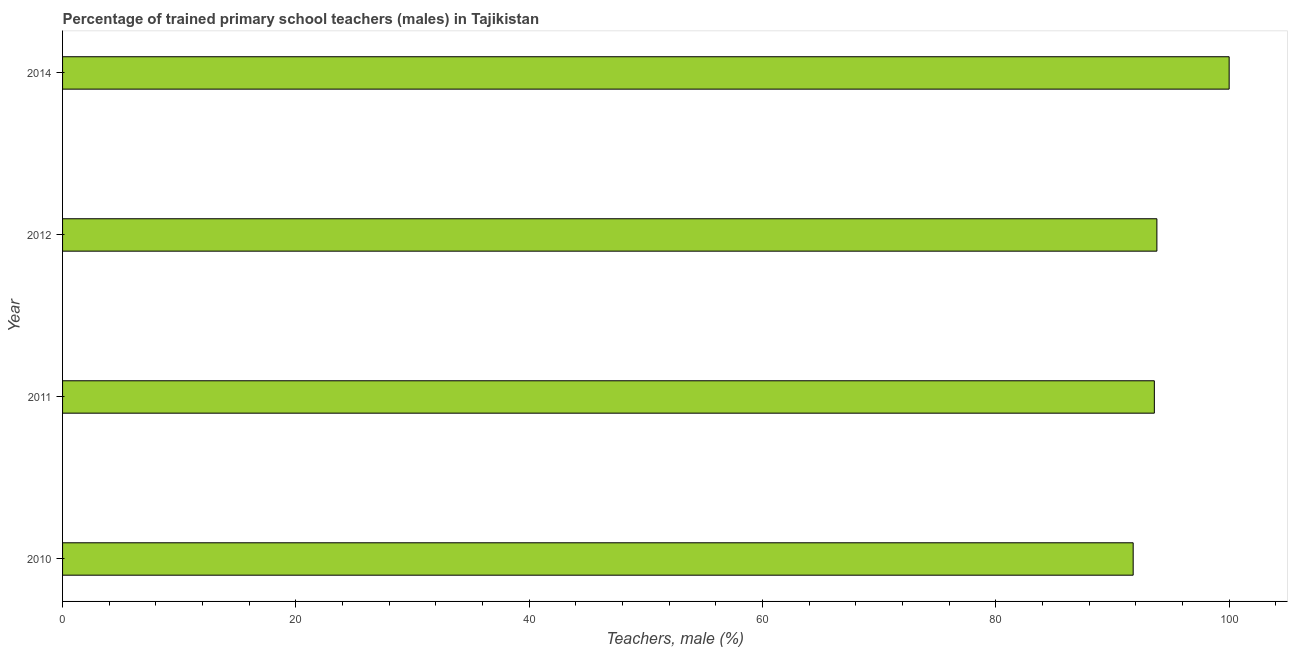Does the graph contain any zero values?
Provide a short and direct response. No. What is the title of the graph?
Your answer should be compact. Percentage of trained primary school teachers (males) in Tajikistan. What is the label or title of the X-axis?
Give a very brief answer. Teachers, male (%). Across all years, what is the minimum percentage of trained male teachers?
Your answer should be compact. 91.77. What is the sum of the percentage of trained male teachers?
Provide a short and direct response. 379.16. What is the difference between the percentage of trained male teachers in 2010 and 2011?
Provide a short and direct response. -1.81. What is the average percentage of trained male teachers per year?
Offer a very short reply. 94.79. What is the median percentage of trained male teachers?
Ensure brevity in your answer.  93.7. In how many years, is the percentage of trained male teachers greater than 68 %?
Provide a succinct answer. 4. Is the percentage of trained male teachers in 2012 less than that in 2014?
Make the answer very short. Yes. What is the difference between the highest and the second highest percentage of trained male teachers?
Provide a short and direct response. 6.2. Is the sum of the percentage of trained male teachers in 2012 and 2014 greater than the maximum percentage of trained male teachers across all years?
Your answer should be very brief. Yes. What is the difference between the highest and the lowest percentage of trained male teachers?
Your answer should be compact. 8.23. In how many years, is the percentage of trained male teachers greater than the average percentage of trained male teachers taken over all years?
Keep it short and to the point. 1. How many bars are there?
Your answer should be very brief. 4. Are the values on the major ticks of X-axis written in scientific E-notation?
Your answer should be very brief. No. What is the Teachers, male (%) in 2010?
Your answer should be very brief. 91.77. What is the Teachers, male (%) of 2011?
Offer a very short reply. 93.59. What is the Teachers, male (%) in 2012?
Make the answer very short. 93.8. What is the Teachers, male (%) in 2014?
Your response must be concise. 100. What is the difference between the Teachers, male (%) in 2010 and 2011?
Your answer should be compact. -1.81. What is the difference between the Teachers, male (%) in 2010 and 2012?
Provide a short and direct response. -2.03. What is the difference between the Teachers, male (%) in 2010 and 2014?
Make the answer very short. -8.23. What is the difference between the Teachers, male (%) in 2011 and 2012?
Your answer should be very brief. -0.22. What is the difference between the Teachers, male (%) in 2011 and 2014?
Keep it short and to the point. -6.41. What is the difference between the Teachers, male (%) in 2012 and 2014?
Provide a succinct answer. -6.2. What is the ratio of the Teachers, male (%) in 2010 to that in 2011?
Keep it short and to the point. 0.98. What is the ratio of the Teachers, male (%) in 2010 to that in 2012?
Provide a short and direct response. 0.98. What is the ratio of the Teachers, male (%) in 2010 to that in 2014?
Keep it short and to the point. 0.92. What is the ratio of the Teachers, male (%) in 2011 to that in 2014?
Your answer should be very brief. 0.94. What is the ratio of the Teachers, male (%) in 2012 to that in 2014?
Your answer should be very brief. 0.94. 